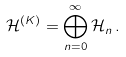Convert formula to latex. <formula><loc_0><loc_0><loc_500><loc_500>\mathcal { H } ^ { ( K ) } = \bigoplus _ { n = 0 } ^ { \infty } \mathcal { H } _ { n } \, .</formula> 